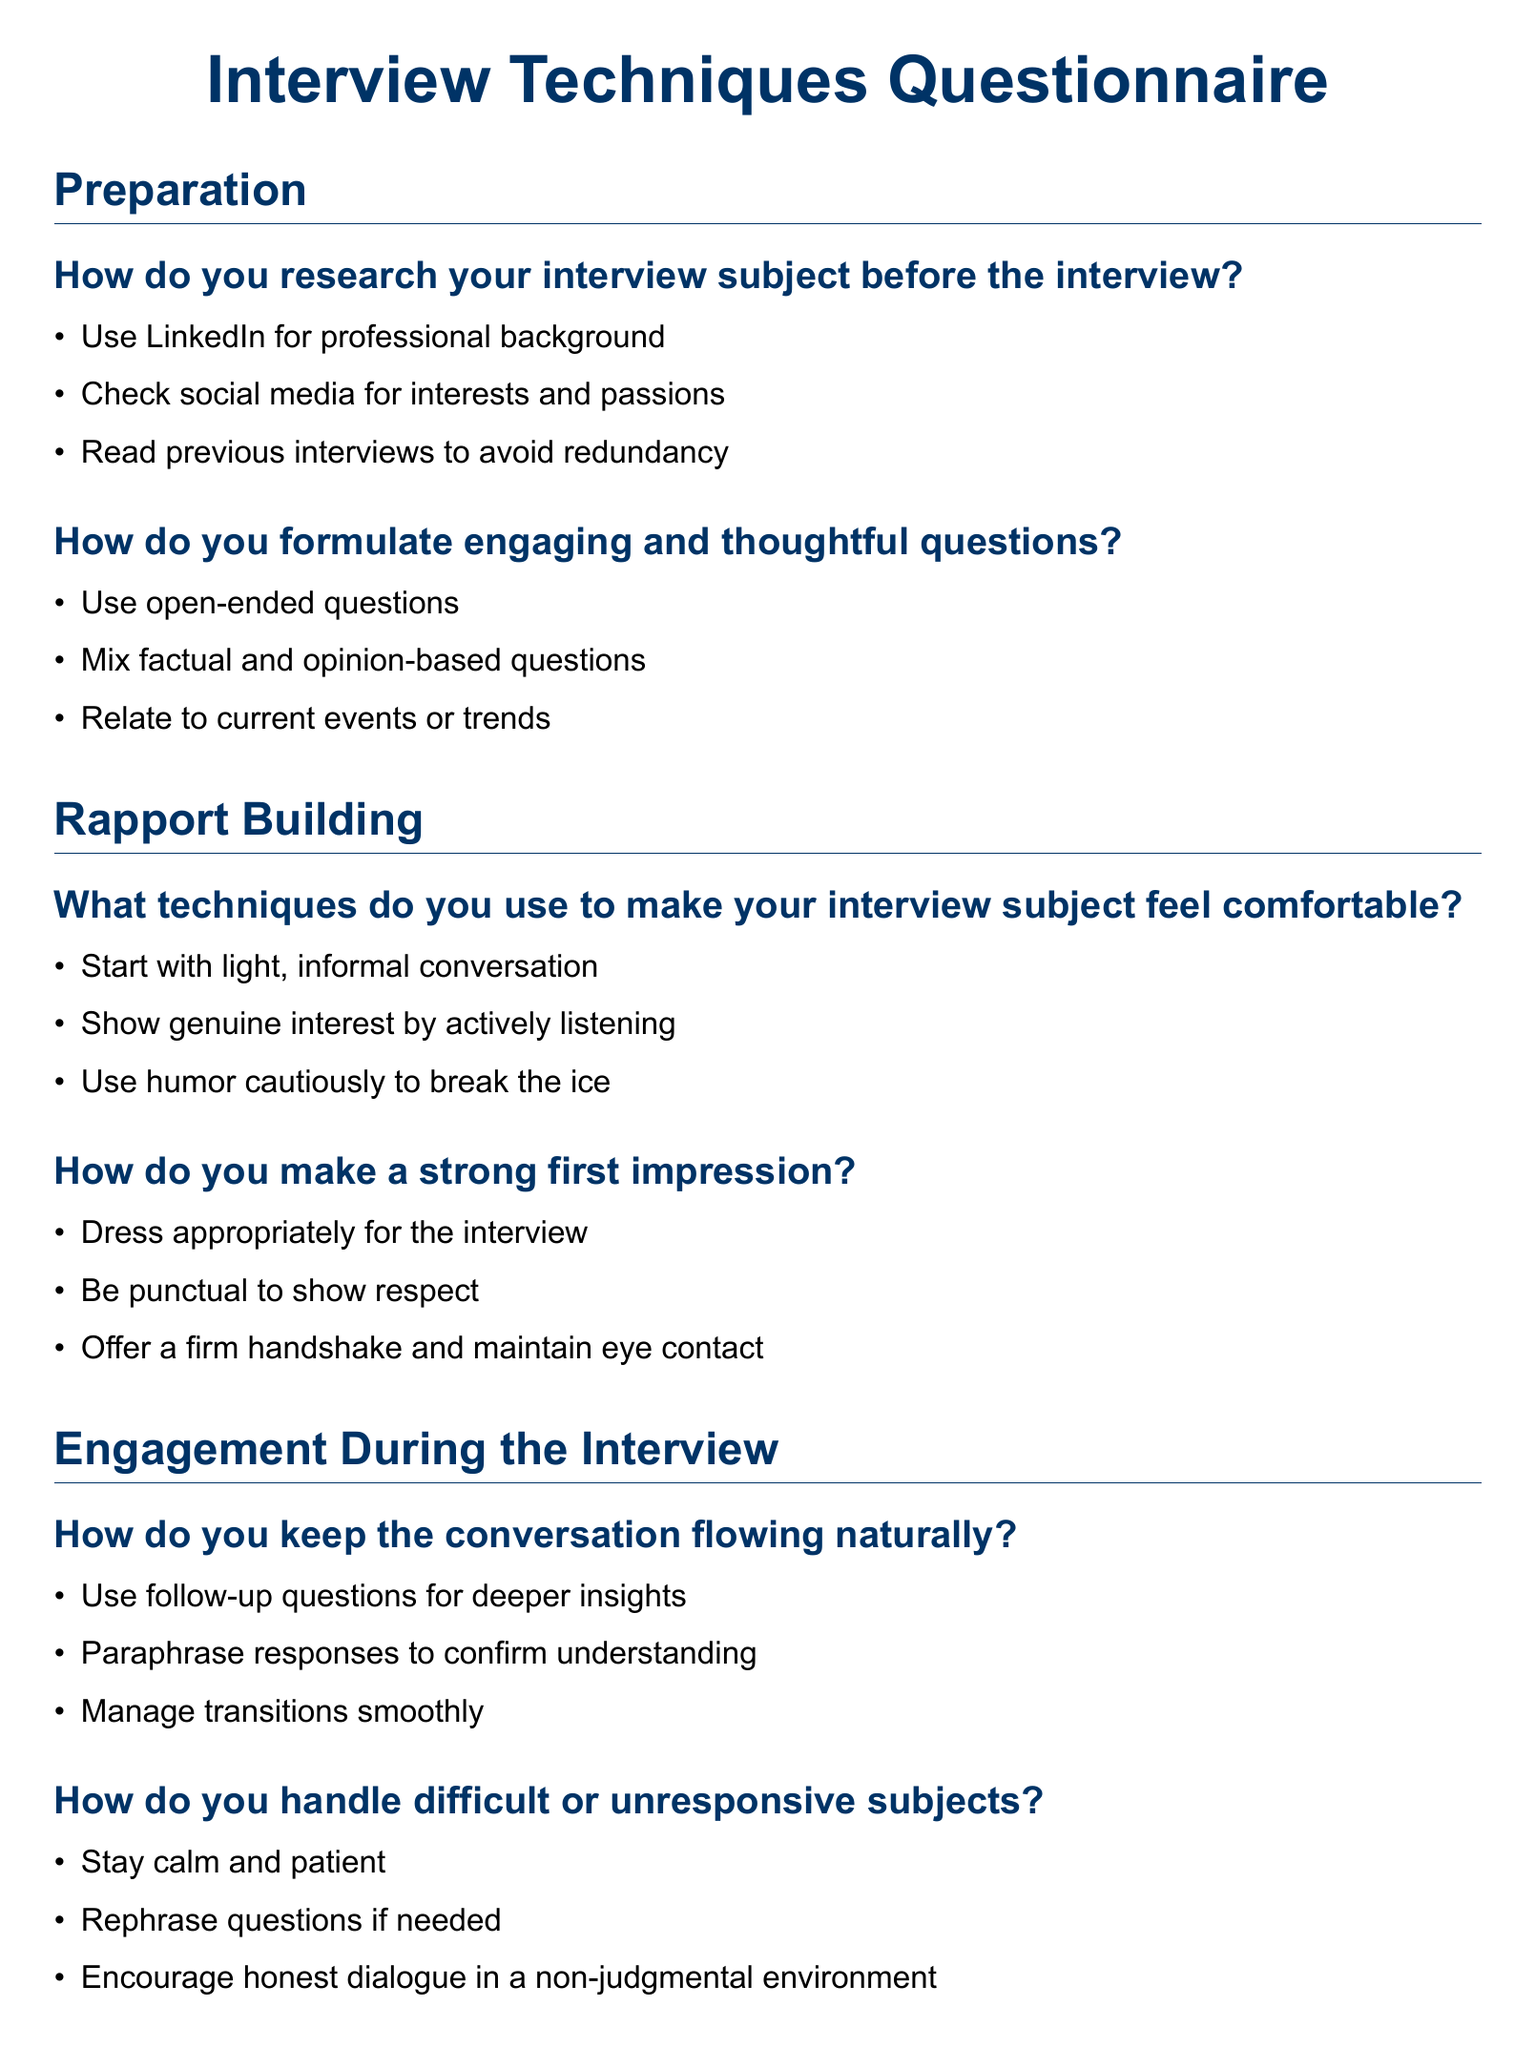What are some platforms used for research? The document lists platforms used for research under the 'Preparation' section, which includes social media and professional networking sites.
Answer: LinkedIn, social media What is one way to make a strong first impression? The answer is found in the 'Rapport Building' section, which highlights actions that contribute to a good first impression.
Answer: Dress appropriately What is a technique to keep the conversation flowing? This is covered in the 'Engagement During the Interview' section, focusing on mechanisms to maintain dialogue during the interview.
Answer: Use follow-up questions How can you handle a difficult subject? The information is provided in the 'Engagement During the Interview' section, detailing strategies for engaging challenging interviewees.
Answer: Stay calm and patient What is a post-interview follow-up action? The 'Post-Interview' section outlines steps to take after the interview, including communication with subjects.
Answer: Send a thank-you email What type of questions should you formulate? The 'Preparation' section discusses the formulation of questions, specifically mentioning their types.
Answer: Open-ended questions What is a technique used to make subjects feel comfortable? This is answered in the 'Rapport Building' section, explaining how to ease interview subjects into the process.
Answer: Start with light, informal conversation 